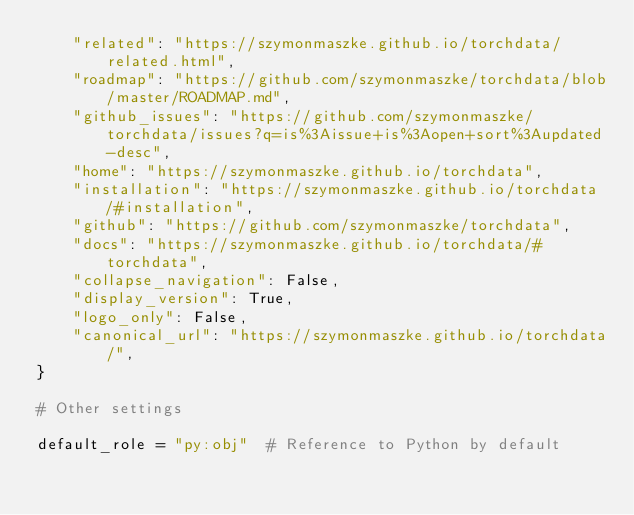Convert code to text. <code><loc_0><loc_0><loc_500><loc_500><_Python_>    "related": "https://szymonmaszke.github.io/torchdata/related.html",
    "roadmap": "https://github.com/szymonmaszke/torchdata/blob/master/ROADMAP.md",
    "github_issues": "https://github.com/szymonmaszke/torchdata/issues?q=is%3Aissue+is%3Aopen+sort%3Aupdated-desc",
    "home": "https://szymonmaszke.github.io/torchdata",
    "installation": "https://szymonmaszke.github.io/torchdata/#installation",
    "github": "https://github.com/szymonmaszke/torchdata",
    "docs": "https://szymonmaszke.github.io/torchdata/#torchdata",
    "collapse_navigation": False,
    "display_version": True,
    "logo_only": False,
    "canonical_url": "https://szymonmaszke.github.io/torchdata/",
}

# Other settings

default_role = "py:obj"  # Reference to Python by default
</code> 